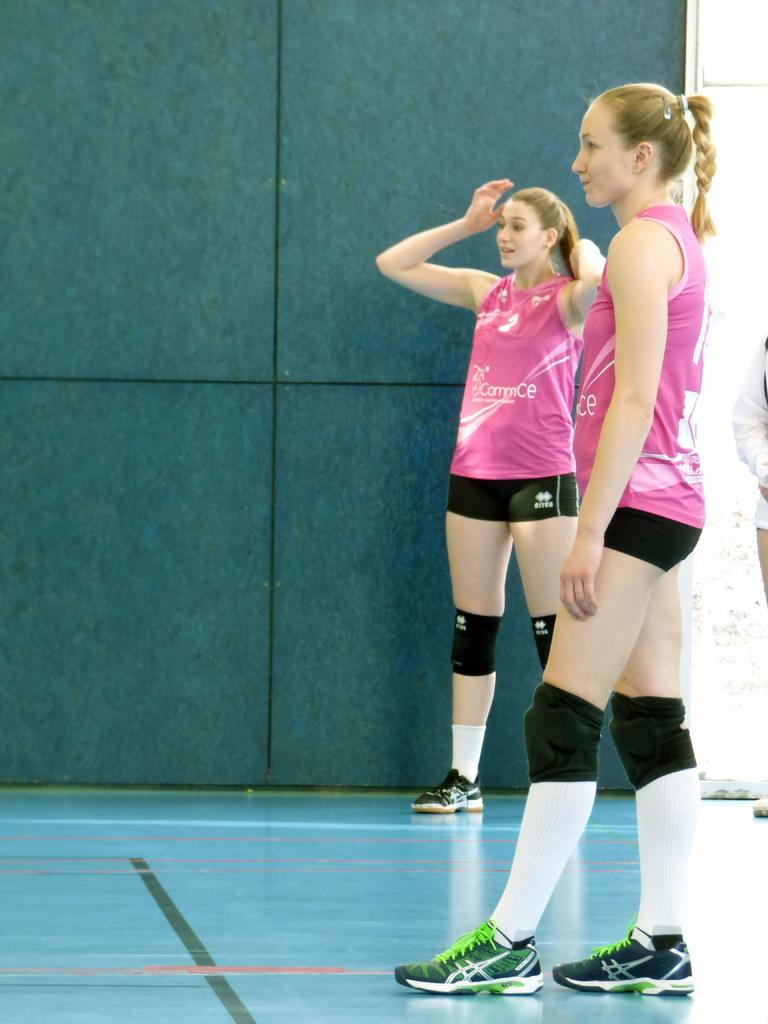How many people are in the image? There are two persons in the image. What colors are the dresses worn by the people in the image? One person is wearing a pink dress, and the other person is wearing a black dress. What is the color of the background in the image? The background of the image is green. What type of leather material is visible in the image? There is no leather material present in the image. What time of day is depicted in the image? The time of day cannot be determined from the image, as there are no specific time-related details provided. 